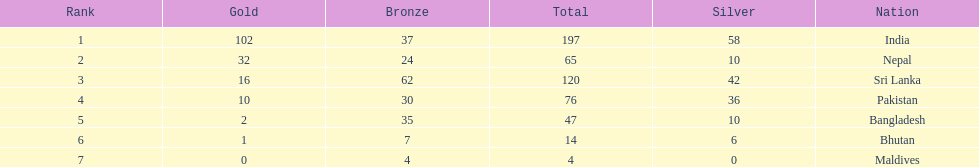Which nation has earned the least amount of gold medals? Maldives. 